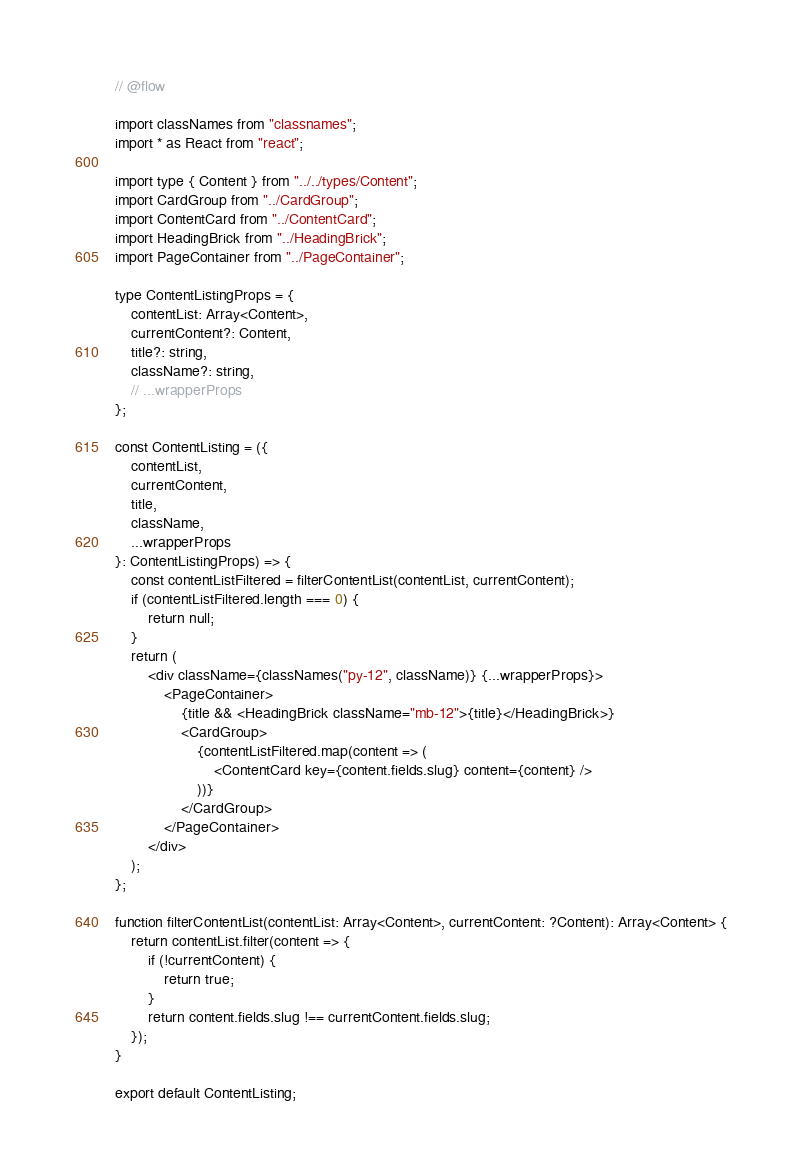<code> <loc_0><loc_0><loc_500><loc_500><_JavaScript_>// @flow

import classNames from "classnames";
import * as React from "react";

import type { Content } from "../../types/Content";
import CardGroup from "../CardGroup";
import ContentCard from "../ContentCard";
import HeadingBrick from "../HeadingBrick";
import PageContainer from "../PageContainer";

type ContentListingProps = {
	contentList: Array<Content>,
	currentContent?: Content,
	title?: string,
	className?: string,
	// ...wrapperProps
};

const ContentListing = ({
	contentList,
	currentContent,
	title,
	className,
	...wrapperProps
}: ContentListingProps) => {
	const contentListFiltered = filterContentList(contentList, currentContent);
	if (contentListFiltered.length === 0) {
		return null;
	}
	return (
		<div className={classNames("py-12", className)} {...wrapperProps}>
			<PageContainer>
				{title && <HeadingBrick className="mb-12">{title}</HeadingBrick>}
				<CardGroup>
					{contentListFiltered.map(content => (
						<ContentCard key={content.fields.slug} content={content} />
					))}
				</CardGroup>
			</PageContainer>
		</div>
	);
};

function filterContentList(contentList: Array<Content>, currentContent: ?Content): Array<Content> {
	return contentList.filter(content => {
		if (!currentContent) {
			return true;
		}
		return content.fields.slug !== currentContent.fields.slug;
	});
}

export default ContentListing;
</code> 